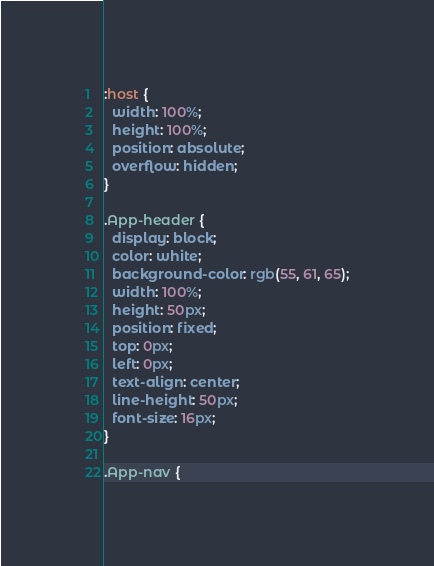<code> <loc_0><loc_0><loc_500><loc_500><_CSS_>:host {
  width: 100%;
  height: 100%;
  position: absolute;
  overflow: hidden;
}

.App-header {
  display: block;
  color: white;
  background-color: rgb(55, 61, 65);
  width: 100%;
  height: 50px;
  position: fixed;
  top: 0px;
  left: 0px;
  text-align: center;
  line-height: 50px;
  font-size: 16px;
}

.App-nav {</code> 